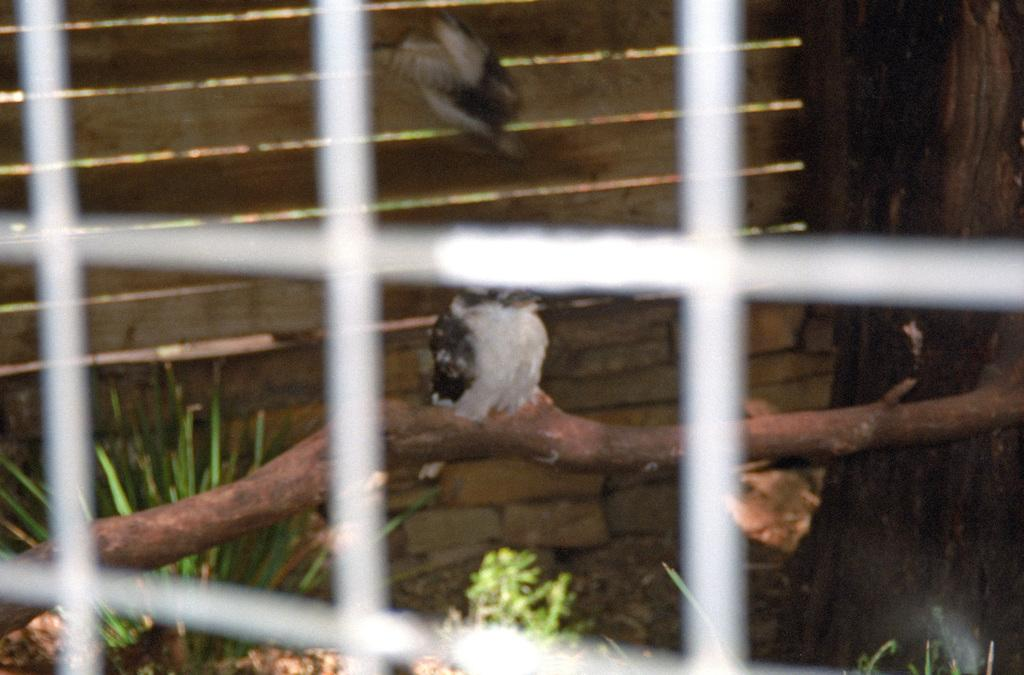What is the main object in the image? There is a net in the image. Can you describe the background of the image? In the background, there is a bird on a wooden stick, grass, plants, a bird in the air, a wooden door, and a truncated tree on the right side. What type of vegetation is present on the ground in the background? Grass and plants are visible on the ground in the background. How many birds can be seen in the image? There are two birds in the image, one on a wooden stick and another in the air. What nation is the bird from in the image? There is no information about the bird's nationality in the image. What is the bird's reaction to the surprise in the image? There is no surprise mentioned in the image, so it is not possible to determine the bird's reaction. 